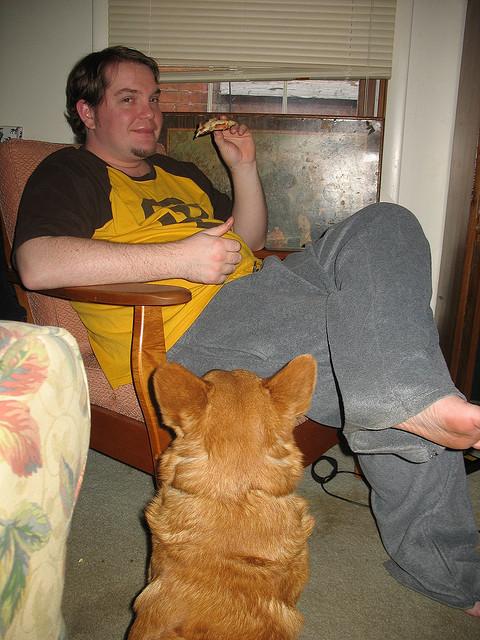Why is the dog looking at the man?
Answer briefly. Food. Is the dog waiting for a treat?
Answer briefly. Yes. Did he share a piece with the dog?
Concise answer only. No. 